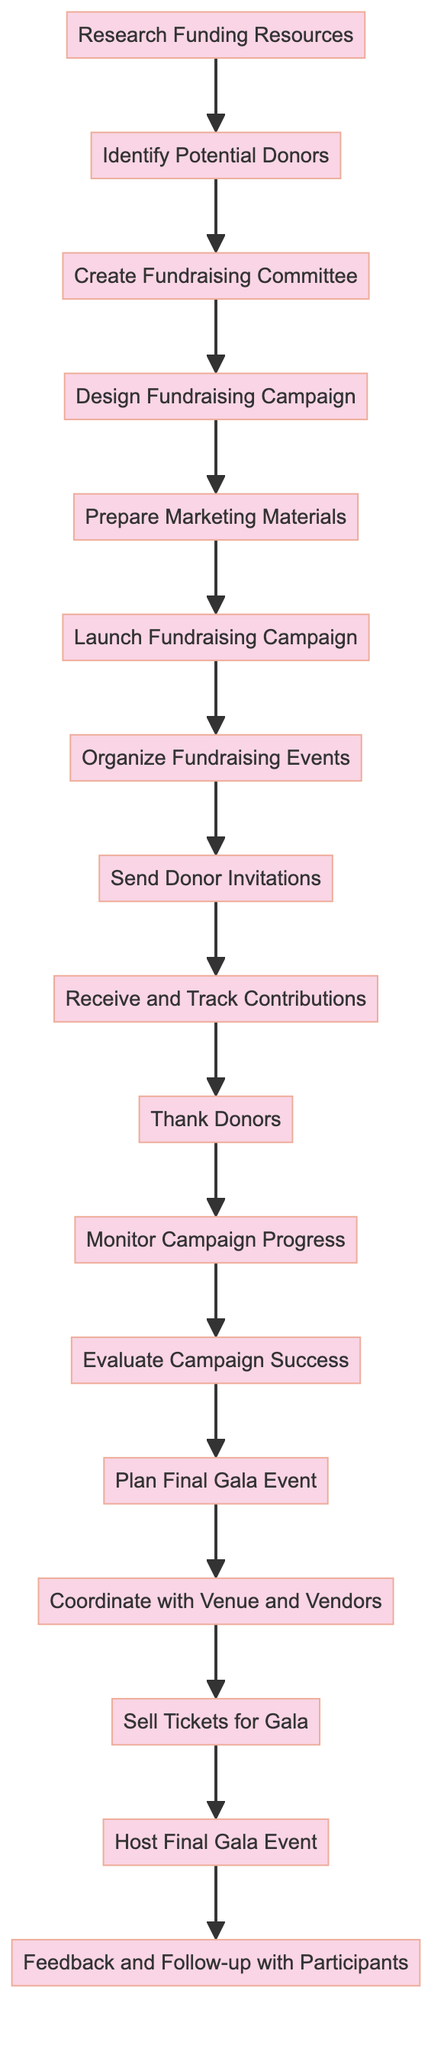What is the first action in the diagram? The first action node in the diagram is labeled "Research Funding Resources" and is positioned at the top of the flow. It initiates the process.
Answer: Research Funding Resources How many action nodes are in the diagram? By counting each distinct action listed in the diagram, we find there are a total of 16 action nodes.
Answer: 16 What action comes after "Design Fundraising Campaign"? The action that follows "Design Fundraising Campaign" is "Prepare Marketing Materials." This can be determined by following the flow from that node to the next.
Answer: Prepare Marketing Materials What are the last two actions before the final gala event? The last two actions before "Host Final Gala Event" are "Sell Tickets for Gala" and "Coordinate with Venue and Vendors," which can be seen directly before the final action in the sequence.
Answer: Sell Tickets for Gala, Coordinate with Venue and Vendors Which action follows "Thank Donors"? The action that follows "Thank Donors" is "Monitor Campaign Progress." This is determined by following the flow from the "Thank Donors" node to the subsequent action.
Answer: Monitor Campaign Progress How many actions involve communication with donors or participants? The actions that involve communication are "Send Donor Invitations," "Thank Donors," and "Feedback and Follow-up with Participants." Thus, there are a total of 3 such actions.
Answer: 3 What is the final action in the diagram? The final action node in the diagram is labeled "Feedback and Follow-up with Participants," which represents the conclusion of the fundraising process.
Answer: Feedback and Follow-up with Participants What action comes directly after "Launch Fundraising Campaign"? "Organize Fundraising Events" comes directly after "Launch Fundraising Campaign," following the sequence laid out in the diagram.
Answer: Organize Fundraising Events What is the relationship between "Evaluate Campaign Success" and "Plan Final Gala Event"? "Evaluate Campaign Success" precedes "Plan Final Gala Event," suggesting that the evaluation of the campaign's success is a prerequisite for planning the final event.
Answer: Precedes 